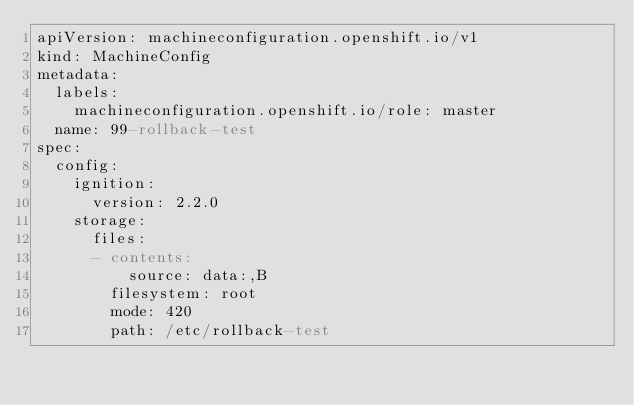Convert code to text. <code><loc_0><loc_0><loc_500><loc_500><_YAML_>apiVersion: machineconfiguration.openshift.io/v1
kind: MachineConfig
metadata:
  labels:
    machineconfiguration.openshift.io/role: master
  name: 99-rollback-test
spec:
  config:
    ignition:
      version: 2.2.0
    storage:
      files:
      - contents:
          source: data:,B
        filesystem: root
        mode: 420
        path: /etc/rollback-test
</code> 